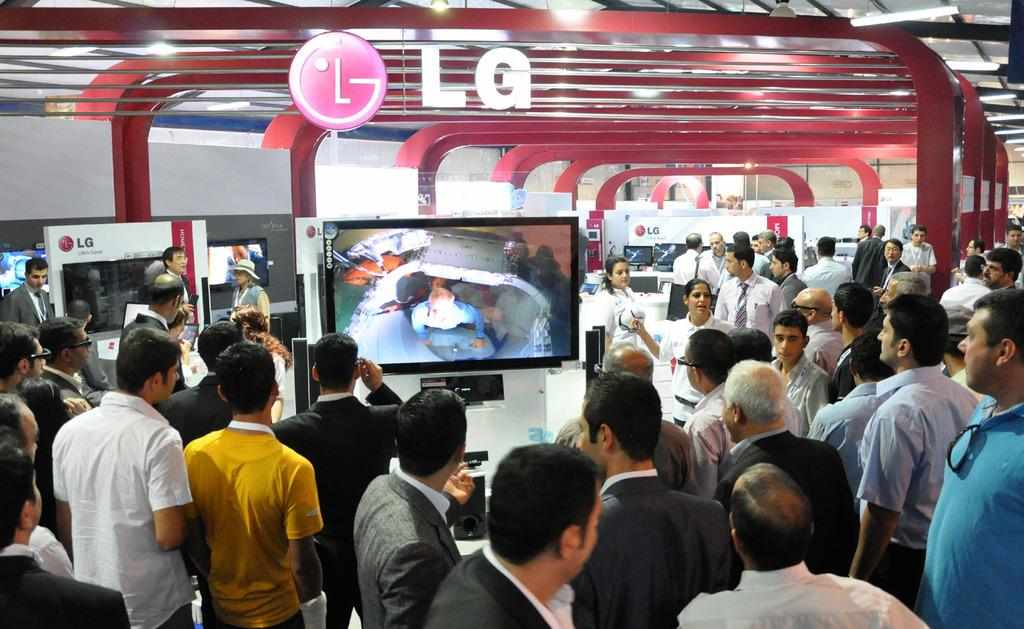What can be seen in the image involving people? There are people standing in the image. What electronic devices are present in the image? There are TVs in the image. What is visible at the top of the image? There is a ceiling with rods visible at the top of the image. Are there any words or letters on the ceiling? Yes, there is some text on the ceiling. What type of current is flowing through the rods on the ceiling? There is no information about any current flowing through the rods on the ceiling in the image. 